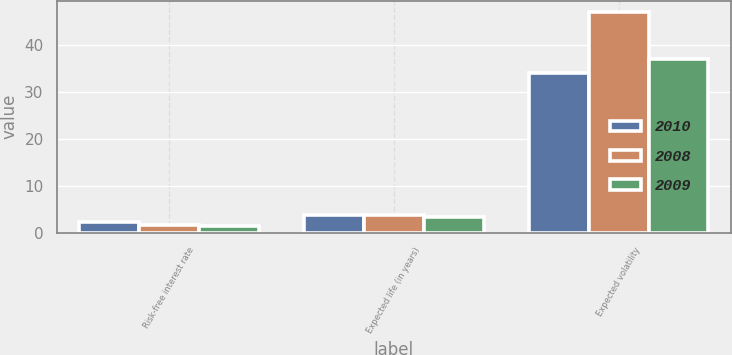Convert chart to OTSL. <chart><loc_0><loc_0><loc_500><loc_500><stacked_bar_chart><ecel><fcel>Risk-free interest rate<fcel>Expected life (in years)<fcel>Expected volatility<nl><fcel>2010<fcel>2.3<fcel>3.8<fcel>34<nl><fcel>2008<fcel>1.7<fcel>3.8<fcel>47<nl><fcel>2009<fcel>1.4<fcel>3.4<fcel>37<nl></chart> 